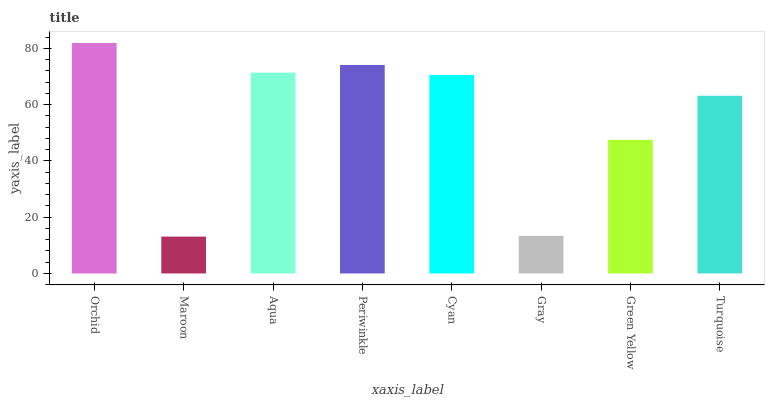Is Maroon the minimum?
Answer yes or no. Yes. Is Orchid the maximum?
Answer yes or no. Yes. Is Aqua the minimum?
Answer yes or no. No. Is Aqua the maximum?
Answer yes or no. No. Is Aqua greater than Maroon?
Answer yes or no. Yes. Is Maroon less than Aqua?
Answer yes or no. Yes. Is Maroon greater than Aqua?
Answer yes or no. No. Is Aqua less than Maroon?
Answer yes or no. No. Is Cyan the high median?
Answer yes or no. Yes. Is Turquoise the low median?
Answer yes or no. Yes. Is Periwinkle the high median?
Answer yes or no. No. Is Gray the low median?
Answer yes or no. No. 